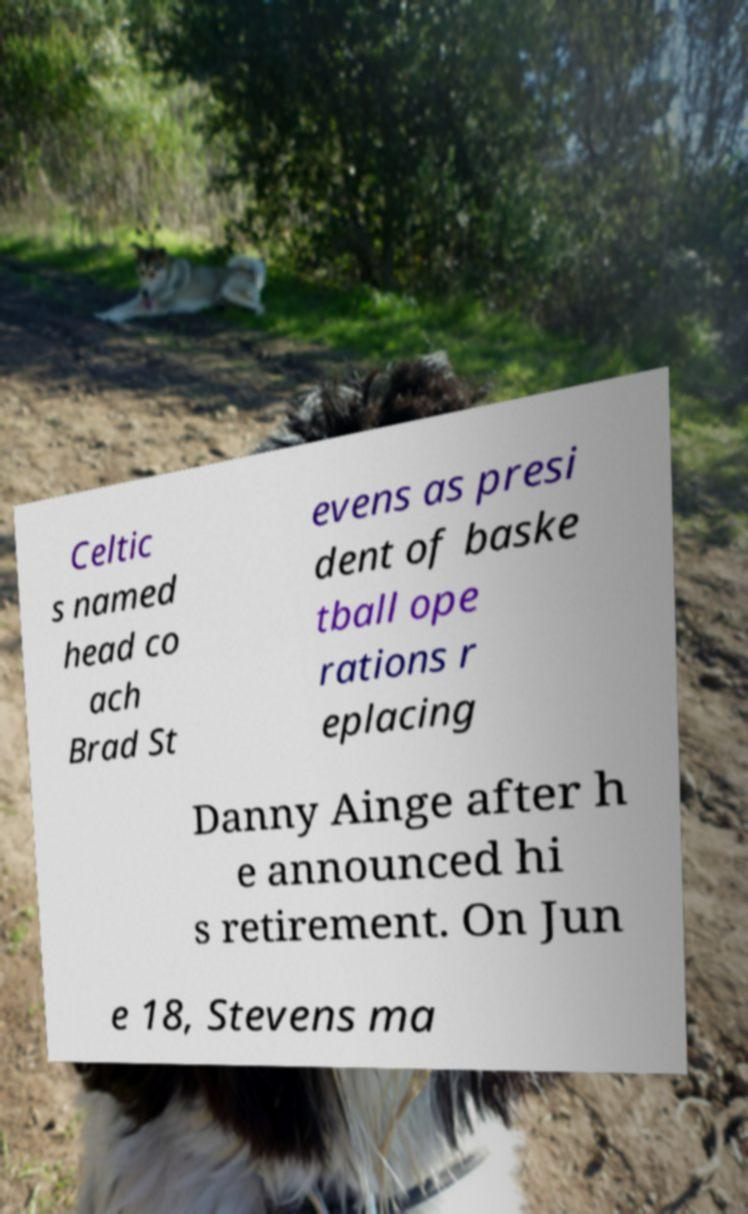Please identify and transcribe the text found in this image. Celtic s named head co ach Brad St evens as presi dent of baske tball ope rations r eplacing Danny Ainge after h e announced hi s retirement. On Jun e 18, Stevens ma 